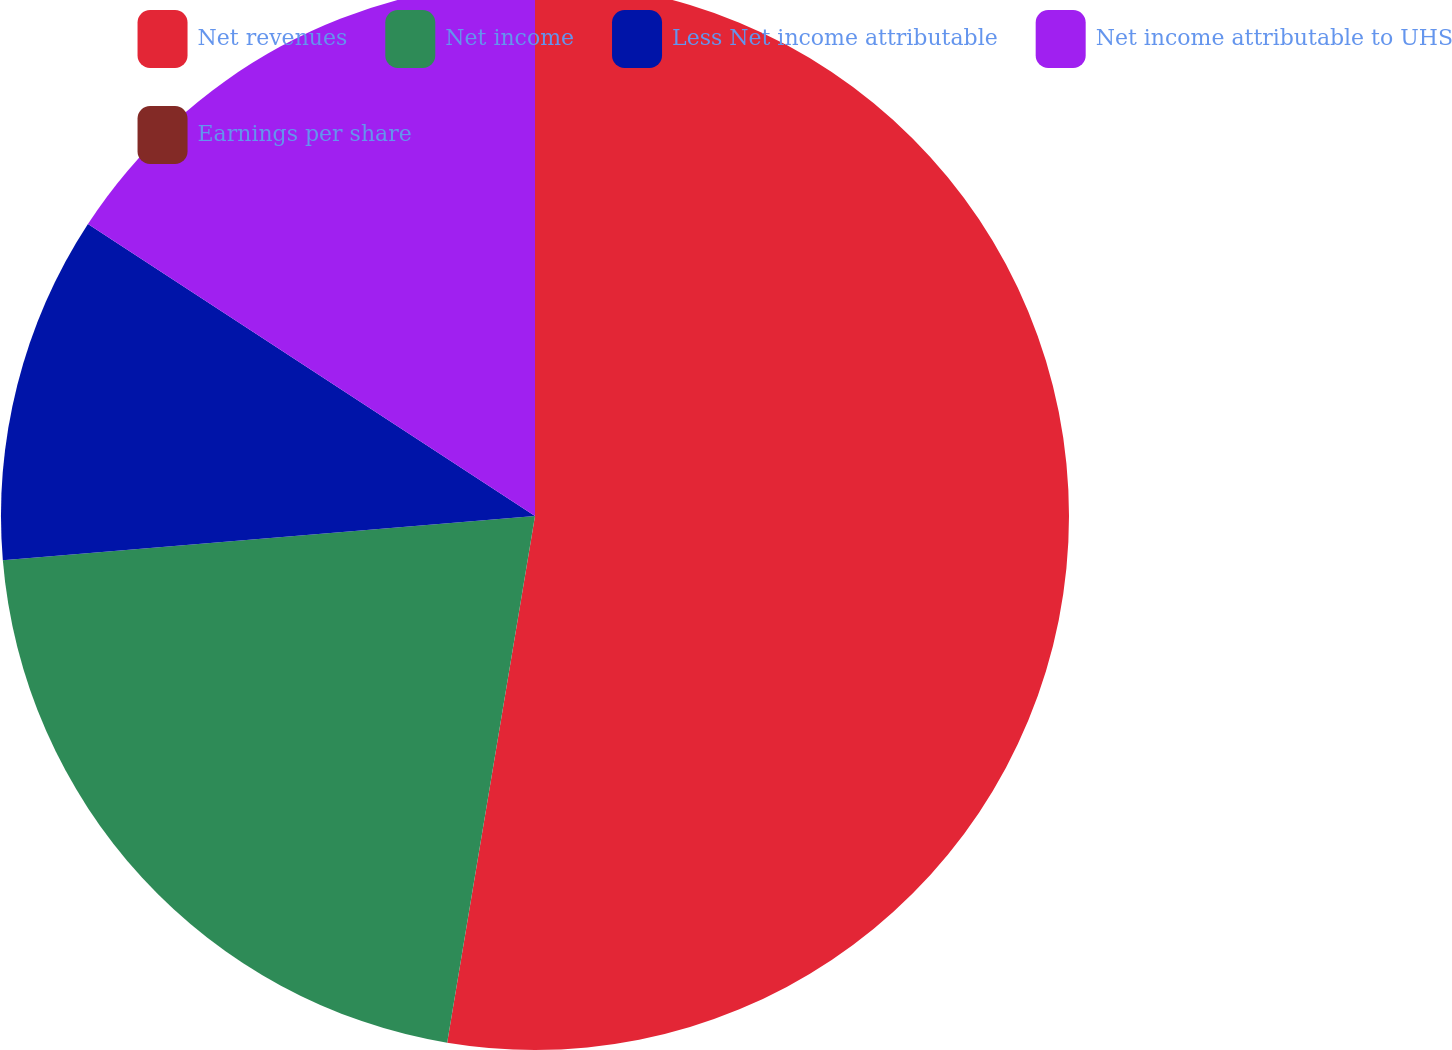<chart> <loc_0><loc_0><loc_500><loc_500><pie_chart><fcel>Net revenues<fcel>Net income<fcel>Less Net income attributable<fcel>Net income attributable to UHS<fcel>Earnings per share<nl><fcel>52.63%<fcel>21.05%<fcel>10.53%<fcel>15.79%<fcel>0.0%<nl></chart> 